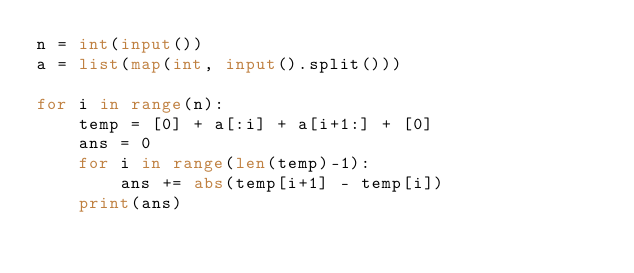<code> <loc_0><loc_0><loc_500><loc_500><_Python_>n = int(input())
a = list(map(int, input().split()))

for i in range(n):
    temp = [0] + a[:i] + a[i+1:] + [0]
    ans = 0
    for i in range(len(temp)-1):
        ans += abs(temp[i+1] - temp[i])
    print(ans)</code> 